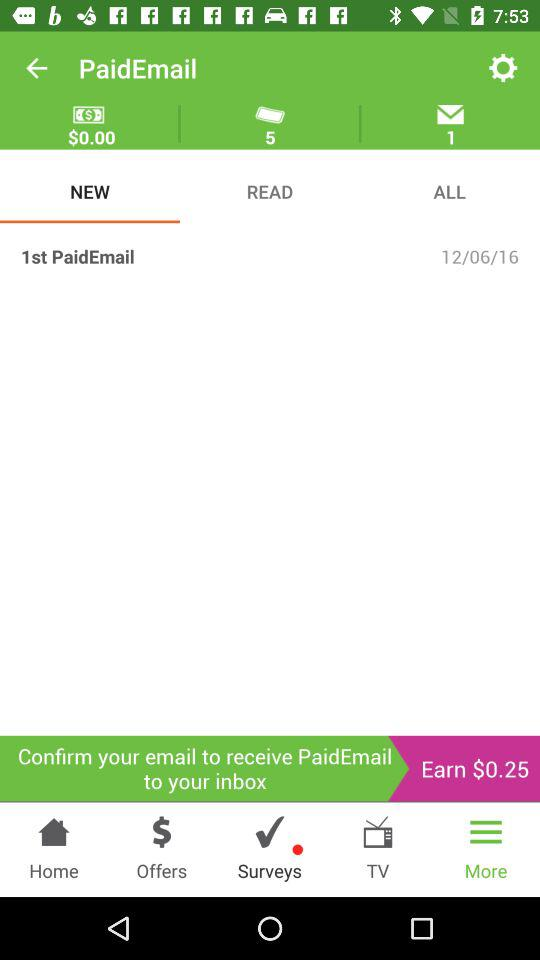What is the name of the application? The application name is "PaidEmail". 